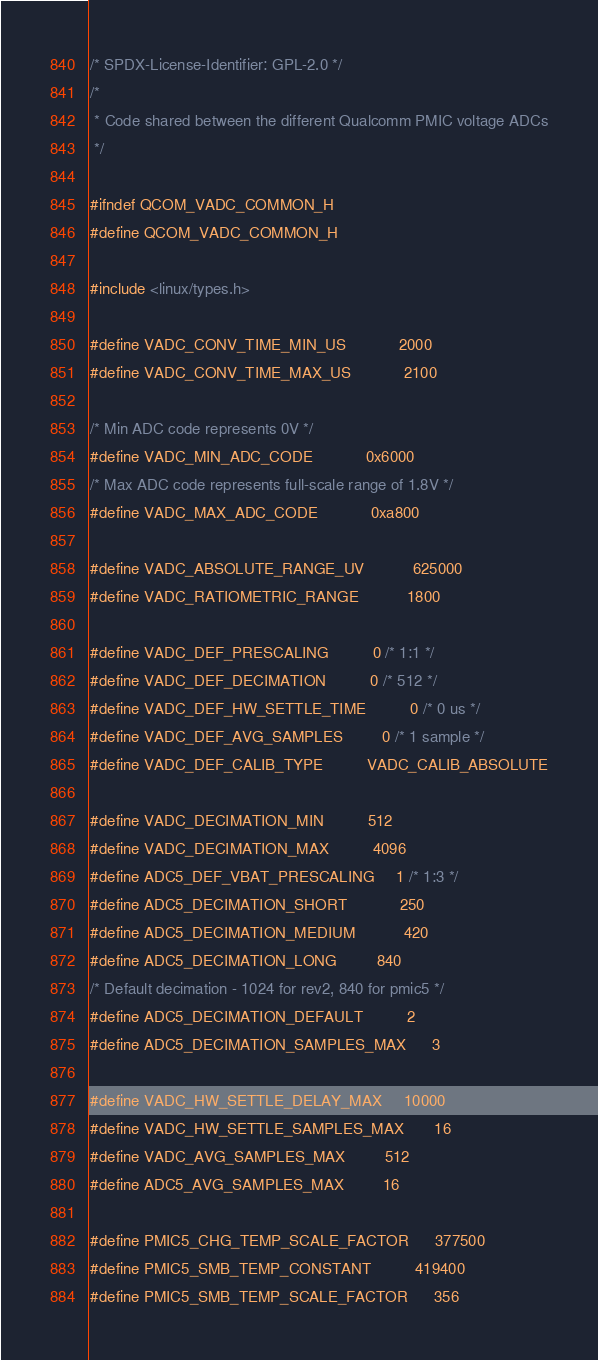Convert code to text. <code><loc_0><loc_0><loc_500><loc_500><_C_>/* SPDX-License-Identifier: GPL-2.0 */
/*
 * Code shared between the different Qualcomm PMIC voltage ADCs
 */

#ifndef QCOM_VADC_COMMON_H
#define QCOM_VADC_COMMON_H

#include <linux/types.h>

#define VADC_CONV_TIME_MIN_US			2000
#define VADC_CONV_TIME_MAX_US			2100

/* Min ADC code represents 0V */
#define VADC_MIN_ADC_CODE			0x6000
/* Max ADC code represents full-scale range of 1.8V */
#define VADC_MAX_ADC_CODE			0xa800

#define VADC_ABSOLUTE_RANGE_UV			625000
#define VADC_RATIOMETRIC_RANGE			1800

#define VADC_DEF_PRESCALING			0 /* 1:1 */
#define VADC_DEF_DECIMATION			0 /* 512 */
#define VADC_DEF_HW_SETTLE_TIME			0 /* 0 us */
#define VADC_DEF_AVG_SAMPLES			0 /* 1 sample */
#define VADC_DEF_CALIB_TYPE			VADC_CALIB_ABSOLUTE

#define VADC_DECIMATION_MIN			512
#define VADC_DECIMATION_MAX			4096
#define ADC5_DEF_VBAT_PRESCALING		1 /* 1:3 */
#define ADC5_DECIMATION_SHORT			250
#define ADC5_DECIMATION_MEDIUM			420
#define ADC5_DECIMATION_LONG			840
/* Default decimation - 1024 for rev2, 840 for pmic5 */
#define ADC5_DECIMATION_DEFAULT			2
#define ADC5_DECIMATION_SAMPLES_MAX		3

#define VADC_HW_SETTLE_DELAY_MAX		10000
#define VADC_HW_SETTLE_SAMPLES_MAX		16
#define VADC_AVG_SAMPLES_MAX			512
#define ADC5_AVG_SAMPLES_MAX			16

#define PMIC5_CHG_TEMP_SCALE_FACTOR		377500
#define PMIC5_SMB_TEMP_CONSTANT			419400
#define PMIC5_SMB_TEMP_SCALE_FACTOR		356
</code> 